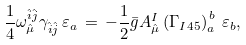Convert formula to latex. <formula><loc_0><loc_0><loc_500><loc_500>\frac { 1 } { 4 } \omega _ { \hat { \mu } } ^ { \hat { i } \hat { j } } \gamma _ { \hat { i } \hat { j } } \, \varepsilon _ { a } \, = \, - \frac { 1 } { 2 } \bar { g } A _ { \hat { \mu } } ^ { I } \left ( \Gamma _ { I 4 5 } \right ) _ { a } ^ { \, b } \, \varepsilon _ { b } ,</formula> 